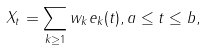<formula> <loc_0><loc_0><loc_500><loc_500>X _ { t } = \sum _ { k \geq 1 } w _ { k } e _ { k } ( t ) , a \leq t \leq b ,</formula> 